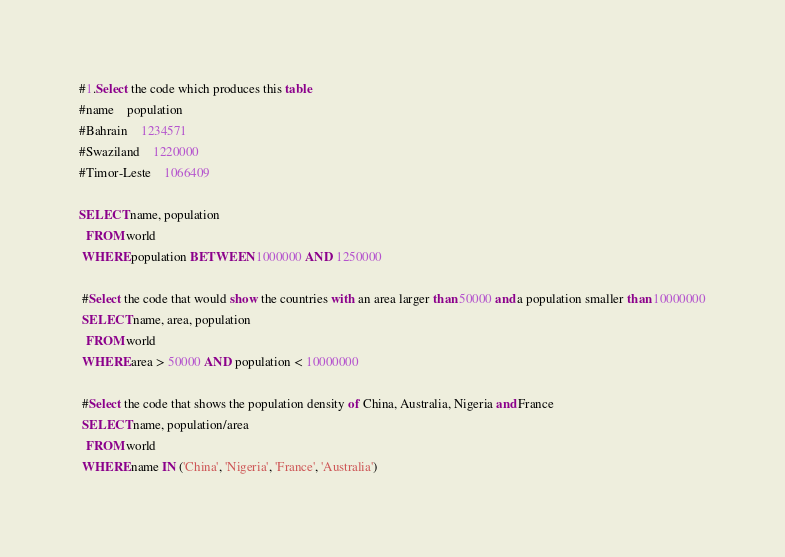<code> <loc_0><loc_0><loc_500><loc_500><_SQL_>#1.Select the code which produces this table
#name	population
#Bahrain	1234571
#Swaziland	1220000
#Timor-Leste	1066409

SELECT name, population
  FROM world
 WHERE population BETWEEN 1000000 AND 1250000
 
 #Select the code that would show the countries with an area larger than 50000 and a population smaller than 10000000
 SELECT name, area, population
  FROM world
 WHERE area > 50000 AND population < 10000000
 
 #Select the code that shows the population density of China, Australia, Nigeria and France
 SELECT name, population/area
  FROM world
 WHERE name IN ('China', 'Nigeria', 'France', 'Australia')</code> 